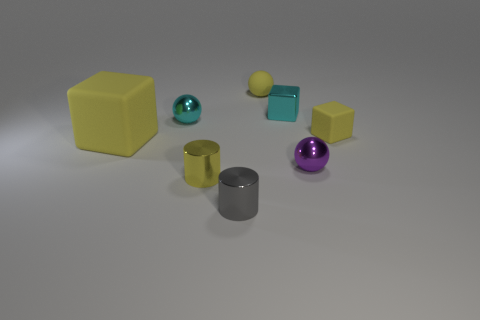Subtract all yellow matte blocks. How many blocks are left? 1 Subtract all brown balls. How many yellow cubes are left? 2 Subtract 1 spheres. How many spheres are left? 2 Subtract all purple blocks. Subtract all red cylinders. How many blocks are left? 3 Add 1 yellow cylinders. How many objects exist? 9 Subtract all blocks. How many objects are left? 5 Subtract 0 purple cubes. How many objects are left? 8 Subtract all purple metallic balls. Subtract all yellow metallic objects. How many objects are left? 6 Add 5 matte cubes. How many matte cubes are left? 7 Add 4 purple metallic spheres. How many purple metallic spheres exist? 5 